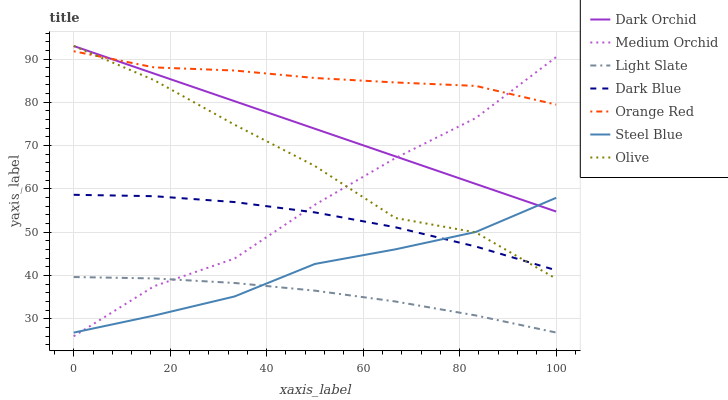Does Light Slate have the minimum area under the curve?
Answer yes or no. Yes. Does Orange Red have the maximum area under the curve?
Answer yes or no. Yes. Does Medium Orchid have the minimum area under the curve?
Answer yes or no. No. Does Medium Orchid have the maximum area under the curve?
Answer yes or no. No. Is Dark Orchid the smoothest?
Answer yes or no. Yes. Is Olive the roughest?
Answer yes or no. Yes. Is Medium Orchid the smoothest?
Answer yes or no. No. Is Medium Orchid the roughest?
Answer yes or no. No. Does Steel Blue have the lowest value?
Answer yes or no. No. Does Medium Orchid have the highest value?
Answer yes or no. No. Is Light Slate less than Orange Red?
Answer yes or no. Yes. Is Orange Red greater than Dark Blue?
Answer yes or no. Yes. Does Light Slate intersect Orange Red?
Answer yes or no. No. 